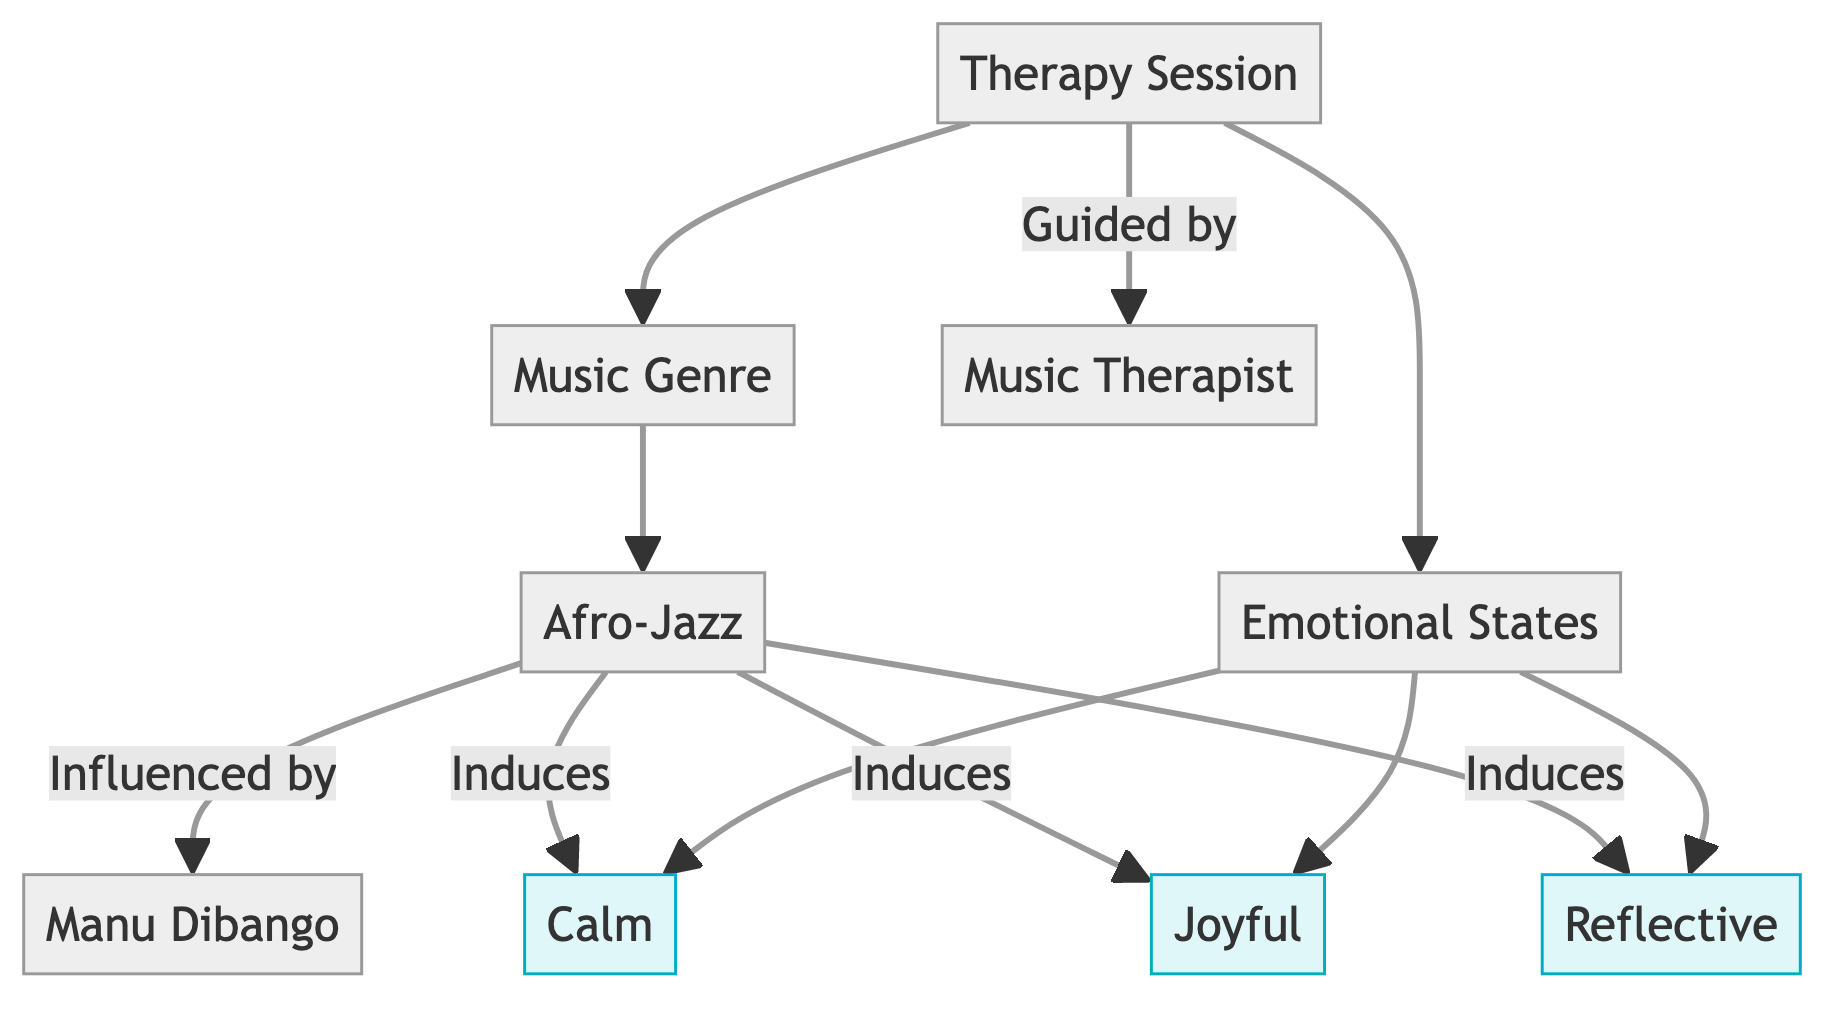What is the root node of the diagram? The root node is the starting point of the directed graph, which is "Music Genre."
Answer: Music Genre How many emotional states are represented in the diagram? The diagram lists three distinct emotional states: Calm, Joyful, and Reflective, which can be counted directly from the nodes.
Answer: 3 What music genre induces the state of Calm? The edge between "Afro-Jazz" and "Calm" indicates that Afro-Jazz is the genre that induces this emotional state.
Answer: Afro-Jazz Who influenced the Afro-Jazz genre? The directed edge from "Afro-Jazz" to "Manu Dibango" with the label "Influenced by" defines the relationship indicating that Manu Dibango influenced Afro-Jazz.
Answer: Manu Dibango Which node is guided by the Music Therapist? The edge from "Therapy Session" to "Music Therapist" specifies that the Therapy Session is guided by the Music Therapist.
Answer: Therapy Session What emotional state is connected to the Therapy Session? The diagram shows a direct connection from "Therapy Session" to "Emotional States," indicating that emotional states are related to the therapy process.
Answer: Emotional States Which emotional state is most closely linked to Afro-Jazz? The edges demonstrate that Afro-Jazz induces multiple emotional states, including Calm, Joyful, and Reflective. Identifying the emotional states directly linked to Afro-Jazz shows that all three are equally close.
Answer: Calm, Joyful, Reflective Count the number of edges originating from the Afro-Jazz node. The Afro-Jazz node connects to three emotional states and one influence relationship to Manu Dibango, accounting for a total of four edges.
Answer: 4 What is the relationship between Therapy Session and Music Genre? The directed edge indicates that a Therapy Session is directly related to a Music Genre, signifying an involvement in selecting a music genre for the session.
Answer: Music Genre 